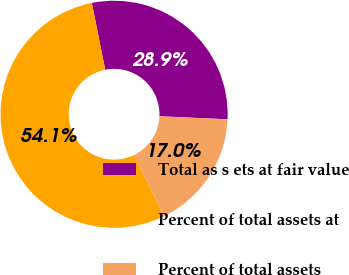Convert chart to OTSL. <chart><loc_0><loc_0><loc_500><loc_500><pie_chart><fcel>Total as s ets at fair value<fcel>Percent of total assets at<fcel>Percent of total assets<nl><fcel>28.85%<fcel>54.1%<fcel>17.04%<nl></chart> 